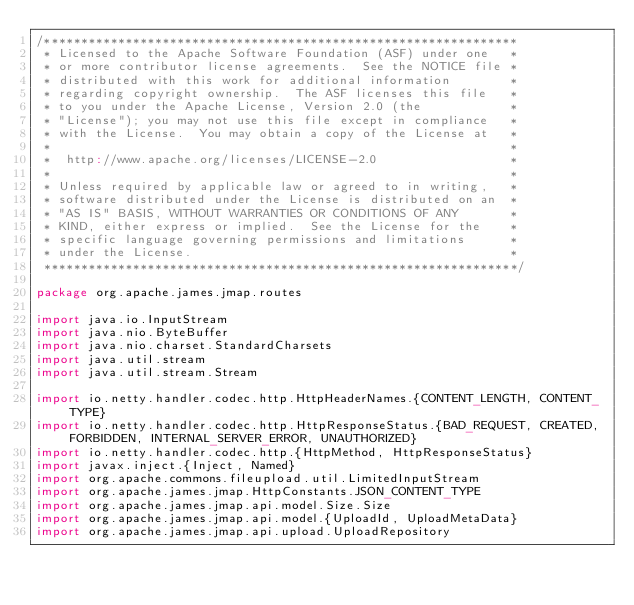<code> <loc_0><loc_0><loc_500><loc_500><_Scala_>/****************************************************************
 * Licensed to the Apache Software Foundation (ASF) under one   *
 * or more contributor license agreements.  See the NOTICE file *
 * distributed with this work for additional information        *
 * regarding copyright ownership.  The ASF licenses this file   *
 * to you under the Apache License, Version 2.0 (the            *
 * "License"); you may not use this file except in compliance   *
 * with the License.  You may obtain a copy of the License at   *
 *                                                              *
 *  http://www.apache.org/licenses/LICENSE-2.0                  *
 *                                                              *
 * Unless required by applicable law or agreed to in writing,   *
 * software distributed under the License is distributed on an  *
 * "AS IS" BASIS, WITHOUT WARRANTIES OR CONDITIONS OF ANY       *
 * KIND, either express or implied.  See the License for the    *
 * specific language governing permissions and limitations      *
 * under the License.                                           *
 ****************************************************************/

package org.apache.james.jmap.routes

import java.io.InputStream
import java.nio.ByteBuffer
import java.nio.charset.StandardCharsets
import java.util.stream
import java.util.stream.Stream

import io.netty.handler.codec.http.HttpHeaderNames.{CONTENT_LENGTH, CONTENT_TYPE}
import io.netty.handler.codec.http.HttpResponseStatus.{BAD_REQUEST, CREATED, FORBIDDEN, INTERNAL_SERVER_ERROR, UNAUTHORIZED}
import io.netty.handler.codec.http.{HttpMethod, HttpResponseStatus}
import javax.inject.{Inject, Named}
import org.apache.commons.fileupload.util.LimitedInputStream
import org.apache.james.jmap.HttpConstants.JSON_CONTENT_TYPE
import org.apache.james.jmap.api.model.Size.Size
import org.apache.james.jmap.api.model.{UploadId, UploadMetaData}
import org.apache.james.jmap.api.upload.UploadRepository</code> 